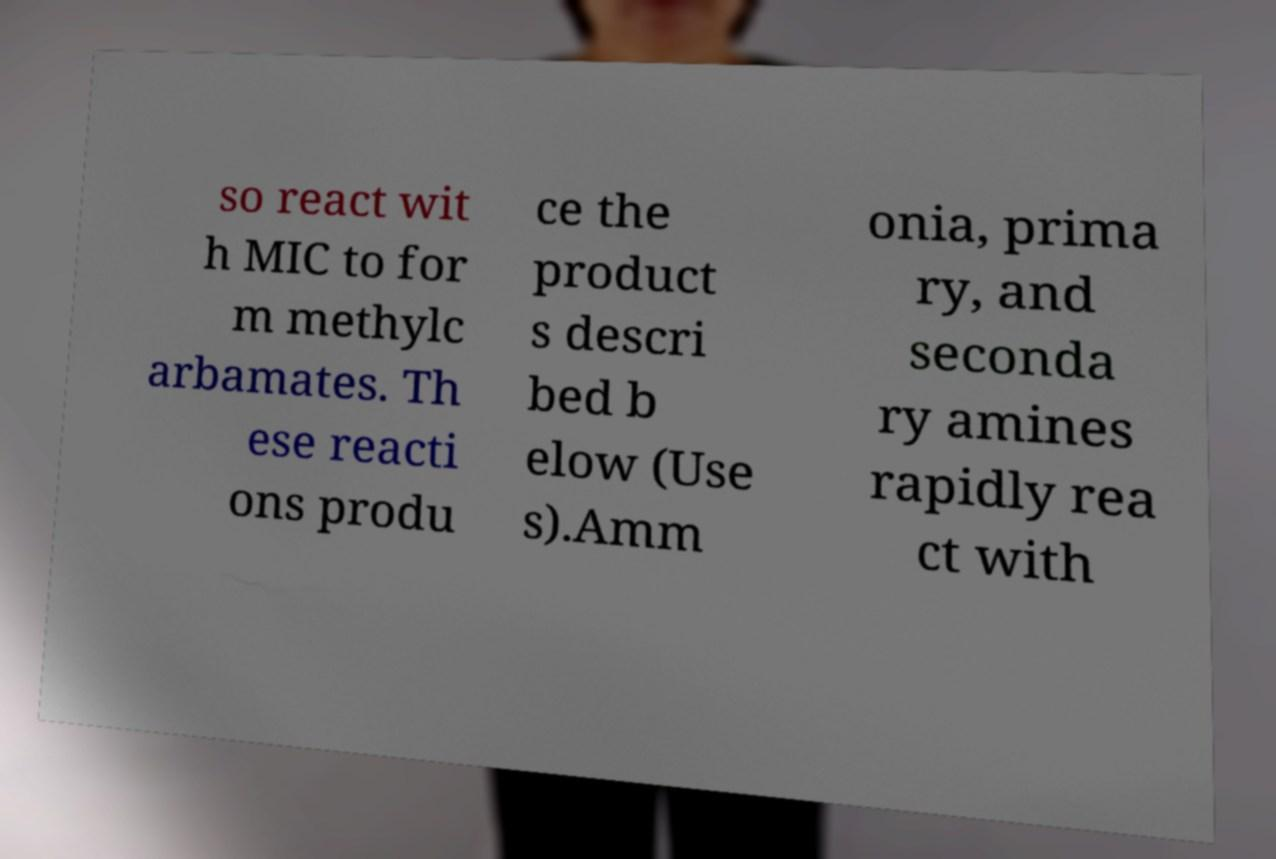Please identify and transcribe the text found in this image. so react wit h MIC to for m methylc arbamates. Th ese reacti ons produ ce the product s descri bed b elow (Use s).Amm onia, prima ry, and seconda ry amines rapidly rea ct with 